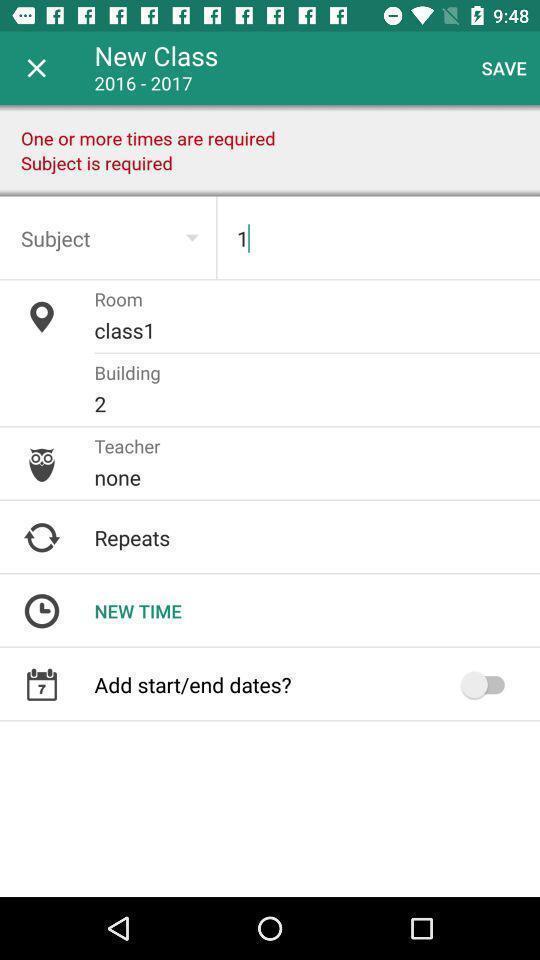Explain the elements present in this screenshot. Screen shows details for class. 